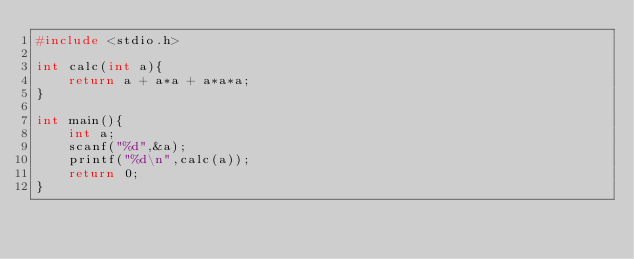<code> <loc_0><loc_0><loc_500><loc_500><_C_>#include <stdio.h>

int calc(int a){
    return a + a*a + a*a*a; 
}

int main(){
    int a;
    scanf("%d",&a);
    printf("%d\n",calc(a));
    return 0;
}</code> 